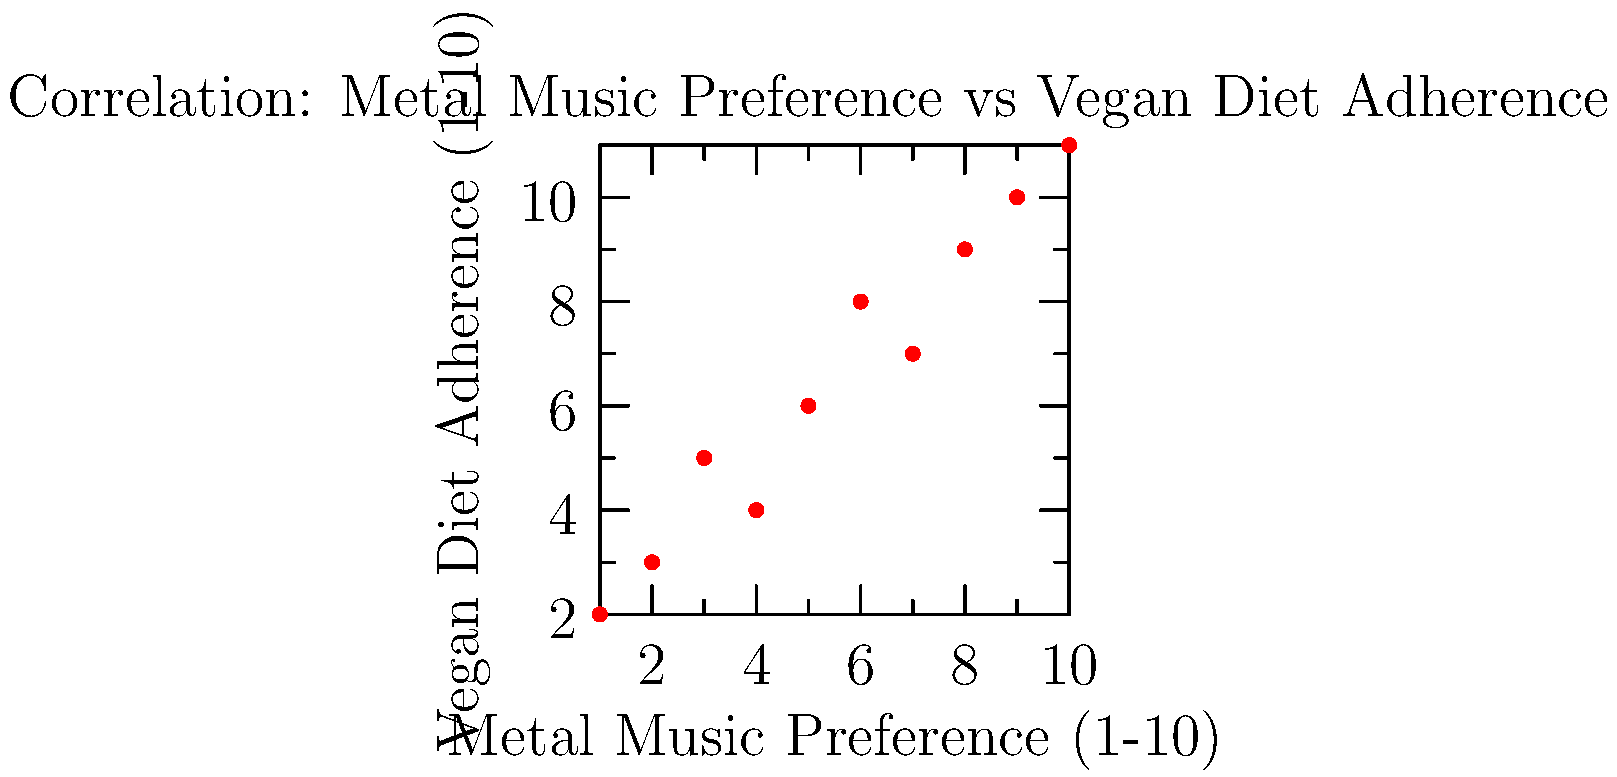Based on the scatter plot shown, which statistical measure would best describe the relationship between metal music preference and vegan diet adherence? Calculate this measure and interpret its meaning in the context of the data. To determine the best statistical measure and interpret the relationship:

1. Observe the scatter plot: There appears to be a positive trend between metal music preference and vegan diet adherence.

2. Given the linear trend, Pearson's correlation coefficient (r) is appropriate.

3. Calculate r using the formula:
   $$r = \frac{\sum_{i=1}^{n} (x_i - \bar{x})(y_i - \bar{y})}{\sqrt{\sum_{i=1}^{n} (x_i - \bar{x})^2 \sum_{i=1}^{n} (y_i - \bar{y})^2}}$$

4. Calculating means:
   $\bar{x} = 5.5$, $\bar{y} = 6.5$

5. Calculate numerator and denominator:
   Numerator = 82.5
   Denominator = $\sqrt{82.5 \times 82.5}$ = 82.5

6. r = 82.5 / 82.5 = 1

7. Interpret r:
   - r = 1 indicates a perfect positive linear correlation
   - This suggests that as metal music preference increases, vegan diet adherence increases proportionally

8. In context: There's a strong positive relationship between metal music preference and vegan diet adherence among the surveyed individuals.
Answer: Pearson's correlation coefficient (r) = 1, indicating a perfect positive linear relationship. 